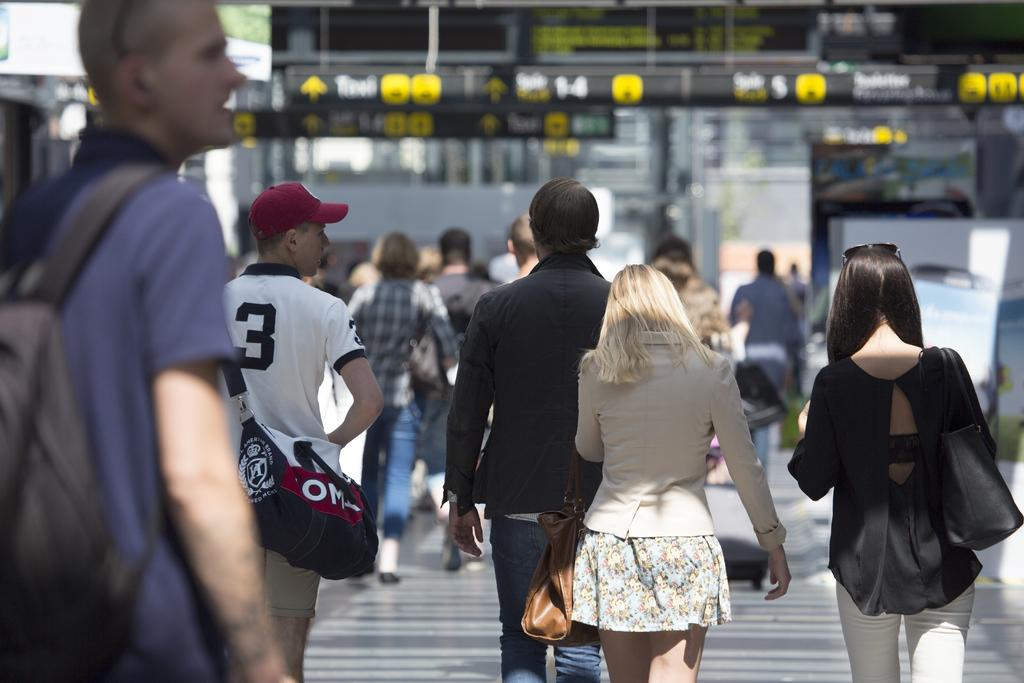What are the people in the image doing? There are many people walking in the image. What are some of the people carrying? Some of the people are carrying bags. Can you describe the appearance of one person in the image? One person is wearing a cap. How would you describe the background of the image? The background of the image is blurry. What type of exchange is taking place between the people in the image? There is no exchange taking place between the people in the image; they are simply walking. 